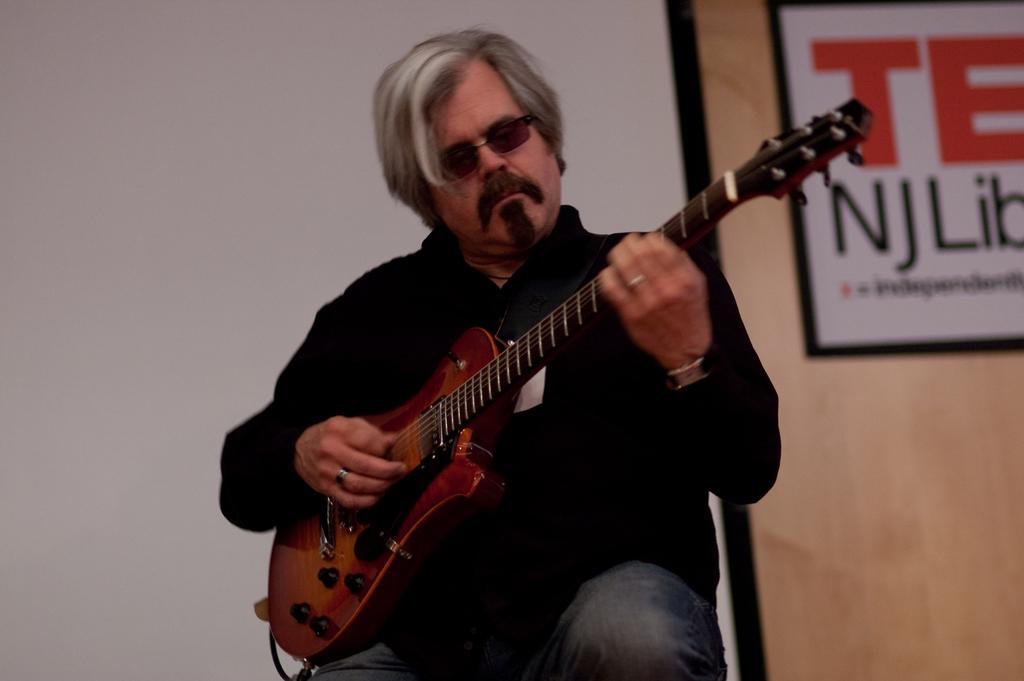In one or two sentences, can you explain what this image depicts? Man here in black jacket is playing guitar. He he is wearing jeans and also spectacles. He is wearing watch. Behind him, we see a banner like on which text is written on it. Behind that, we see a wall which is white in color. 